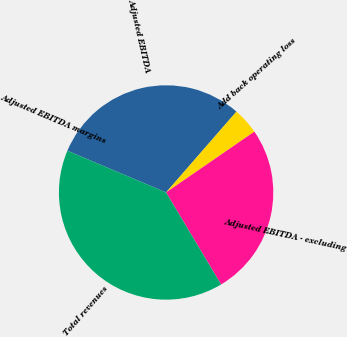Convert chart to OTSL. <chart><loc_0><loc_0><loc_500><loc_500><pie_chart><fcel>Adjusted EBITDA<fcel>Add back operating loss<fcel>Adjusted EBITDA - excluding<fcel>Total revenues<fcel>Adjusted EBITDA margins<nl><fcel>30.03%<fcel>4.0%<fcel>26.03%<fcel>39.94%<fcel>0.0%<nl></chart> 